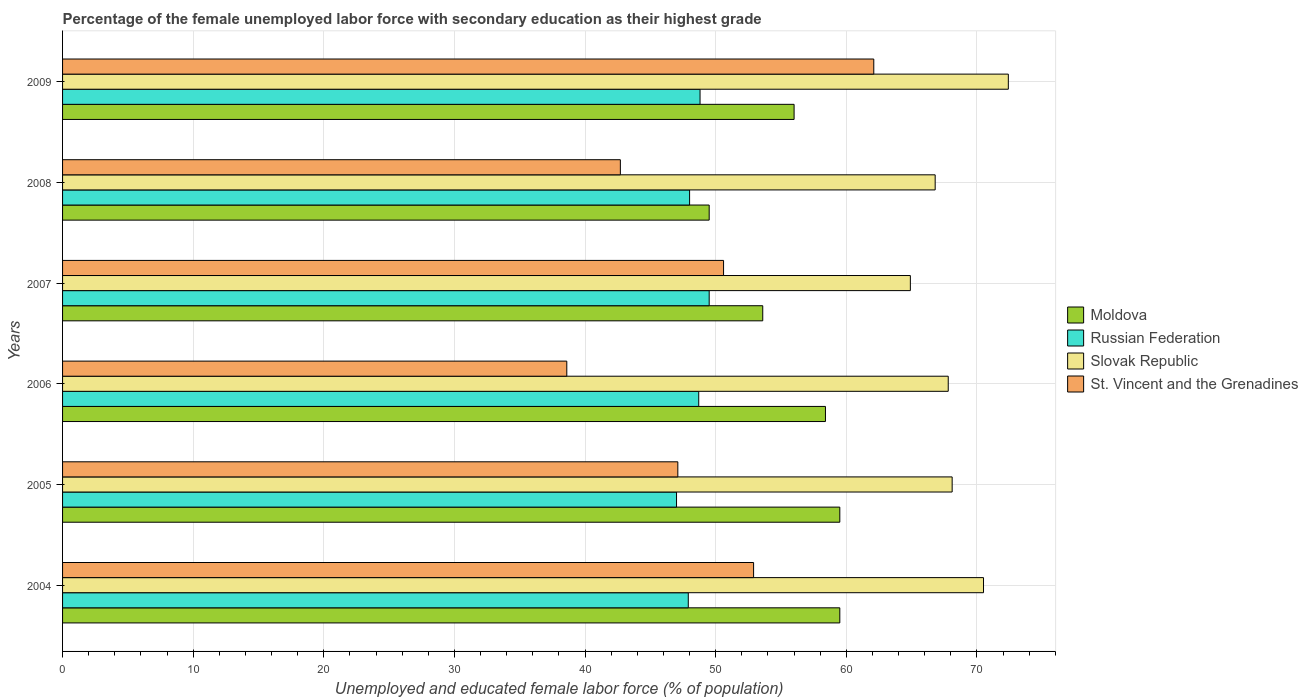How many different coloured bars are there?
Provide a succinct answer. 4. Are the number of bars per tick equal to the number of legend labels?
Your answer should be very brief. Yes. How many bars are there on the 6th tick from the bottom?
Give a very brief answer. 4. In how many cases, is the number of bars for a given year not equal to the number of legend labels?
Provide a succinct answer. 0. What is the percentage of the unemployed female labor force with secondary education in Moldova in 2005?
Ensure brevity in your answer.  59.5. Across all years, what is the maximum percentage of the unemployed female labor force with secondary education in Moldova?
Ensure brevity in your answer.  59.5. In which year was the percentage of the unemployed female labor force with secondary education in Moldova maximum?
Your answer should be compact. 2004. What is the total percentage of the unemployed female labor force with secondary education in St. Vincent and the Grenadines in the graph?
Make the answer very short. 294. What is the difference between the percentage of the unemployed female labor force with secondary education in St. Vincent and the Grenadines in 2006 and that in 2007?
Ensure brevity in your answer.  -12. What is the average percentage of the unemployed female labor force with secondary education in Slovak Republic per year?
Your answer should be very brief. 68.42. In the year 2009, what is the difference between the percentage of the unemployed female labor force with secondary education in Slovak Republic and percentage of the unemployed female labor force with secondary education in St. Vincent and the Grenadines?
Your answer should be compact. 10.3. What is the ratio of the percentage of the unemployed female labor force with secondary education in Russian Federation in 2008 to that in 2009?
Your answer should be compact. 0.98. Is the percentage of the unemployed female labor force with secondary education in Russian Federation in 2004 less than that in 2009?
Provide a succinct answer. Yes. Is the difference between the percentage of the unemployed female labor force with secondary education in Slovak Republic in 2007 and 2009 greater than the difference between the percentage of the unemployed female labor force with secondary education in St. Vincent and the Grenadines in 2007 and 2009?
Provide a short and direct response. Yes. What is the difference between the highest and the second highest percentage of the unemployed female labor force with secondary education in Slovak Republic?
Your answer should be compact. 1.9. What is the difference between the highest and the lowest percentage of the unemployed female labor force with secondary education in Russian Federation?
Keep it short and to the point. 2.5. In how many years, is the percentage of the unemployed female labor force with secondary education in Slovak Republic greater than the average percentage of the unemployed female labor force with secondary education in Slovak Republic taken over all years?
Ensure brevity in your answer.  2. Is the sum of the percentage of the unemployed female labor force with secondary education in Slovak Republic in 2007 and 2008 greater than the maximum percentage of the unemployed female labor force with secondary education in Moldova across all years?
Give a very brief answer. Yes. What does the 4th bar from the top in 2004 represents?
Your response must be concise. Moldova. What does the 2nd bar from the bottom in 2007 represents?
Your answer should be compact. Russian Federation. Is it the case that in every year, the sum of the percentage of the unemployed female labor force with secondary education in St. Vincent and the Grenadines and percentage of the unemployed female labor force with secondary education in Moldova is greater than the percentage of the unemployed female labor force with secondary education in Russian Federation?
Keep it short and to the point. Yes. Are all the bars in the graph horizontal?
Your response must be concise. Yes. What is the difference between two consecutive major ticks on the X-axis?
Ensure brevity in your answer.  10. How many legend labels are there?
Your answer should be very brief. 4. What is the title of the graph?
Offer a very short reply. Percentage of the female unemployed labor force with secondary education as their highest grade. What is the label or title of the X-axis?
Give a very brief answer. Unemployed and educated female labor force (% of population). What is the label or title of the Y-axis?
Offer a terse response. Years. What is the Unemployed and educated female labor force (% of population) of Moldova in 2004?
Keep it short and to the point. 59.5. What is the Unemployed and educated female labor force (% of population) of Russian Federation in 2004?
Provide a short and direct response. 47.9. What is the Unemployed and educated female labor force (% of population) in Slovak Republic in 2004?
Keep it short and to the point. 70.5. What is the Unemployed and educated female labor force (% of population) of St. Vincent and the Grenadines in 2004?
Provide a short and direct response. 52.9. What is the Unemployed and educated female labor force (% of population) in Moldova in 2005?
Your answer should be very brief. 59.5. What is the Unemployed and educated female labor force (% of population) of Slovak Republic in 2005?
Give a very brief answer. 68.1. What is the Unemployed and educated female labor force (% of population) in St. Vincent and the Grenadines in 2005?
Give a very brief answer. 47.1. What is the Unemployed and educated female labor force (% of population) of Moldova in 2006?
Your answer should be very brief. 58.4. What is the Unemployed and educated female labor force (% of population) of Russian Federation in 2006?
Make the answer very short. 48.7. What is the Unemployed and educated female labor force (% of population) of Slovak Republic in 2006?
Offer a terse response. 67.8. What is the Unemployed and educated female labor force (% of population) in St. Vincent and the Grenadines in 2006?
Your response must be concise. 38.6. What is the Unemployed and educated female labor force (% of population) of Moldova in 2007?
Ensure brevity in your answer.  53.6. What is the Unemployed and educated female labor force (% of population) in Russian Federation in 2007?
Make the answer very short. 49.5. What is the Unemployed and educated female labor force (% of population) in Slovak Republic in 2007?
Give a very brief answer. 64.9. What is the Unemployed and educated female labor force (% of population) in St. Vincent and the Grenadines in 2007?
Make the answer very short. 50.6. What is the Unemployed and educated female labor force (% of population) in Moldova in 2008?
Make the answer very short. 49.5. What is the Unemployed and educated female labor force (% of population) in Russian Federation in 2008?
Ensure brevity in your answer.  48. What is the Unemployed and educated female labor force (% of population) in Slovak Republic in 2008?
Your response must be concise. 66.8. What is the Unemployed and educated female labor force (% of population) of St. Vincent and the Grenadines in 2008?
Offer a very short reply. 42.7. What is the Unemployed and educated female labor force (% of population) in Russian Federation in 2009?
Provide a succinct answer. 48.8. What is the Unemployed and educated female labor force (% of population) in Slovak Republic in 2009?
Provide a succinct answer. 72.4. What is the Unemployed and educated female labor force (% of population) of St. Vincent and the Grenadines in 2009?
Make the answer very short. 62.1. Across all years, what is the maximum Unemployed and educated female labor force (% of population) in Moldova?
Offer a very short reply. 59.5. Across all years, what is the maximum Unemployed and educated female labor force (% of population) in Russian Federation?
Ensure brevity in your answer.  49.5. Across all years, what is the maximum Unemployed and educated female labor force (% of population) in Slovak Republic?
Provide a short and direct response. 72.4. Across all years, what is the maximum Unemployed and educated female labor force (% of population) of St. Vincent and the Grenadines?
Your answer should be very brief. 62.1. Across all years, what is the minimum Unemployed and educated female labor force (% of population) in Moldova?
Your response must be concise. 49.5. Across all years, what is the minimum Unemployed and educated female labor force (% of population) in Slovak Republic?
Provide a succinct answer. 64.9. Across all years, what is the minimum Unemployed and educated female labor force (% of population) in St. Vincent and the Grenadines?
Your response must be concise. 38.6. What is the total Unemployed and educated female labor force (% of population) in Moldova in the graph?
Offer a terse response. 336.5. What is the total Unemployed and educated female labor force (% of population) of Russian Federation in the graph?
Provide a succinct answer. 289.9. What is the total Unemployed and educated female labor force (% of population) in Slovak Republic in the graph?
Offer a very short reply. 410.5. What is the total Unemployed and educated female labor force (% of population) of St. Vincent and the Grenadines in the graph?
Keep it short and to the point. 294. What is the difference between the Unemployed and educated female labor force (% of population) in Slovak Republic in 2004 and that in 2005?
Provide a short and direct response. 2.4. What is the difference between the Unemployed and educated female labor force (% of population) in Russian Federation in 2004 and that in 2007?
Offer a very short reply. -1.6. What is the difference between the Unemployed and educated female labor force (% of population) of Slovak Republic in 2004 and that in 2008?
Offer a terse response. 3.7. What is the difference between the Unemployed and educated female labor force (% of population) in Moldova in 2004 and that in 2009?
Ensure brevity in your answer.  3.5. What is the difference between the Unemployed and educated female labor force (% of population) in Russian Federation in 2005 and that in 2006?
Provide a short and direct response. -1.7. What is the difference between the Unemployed and educated female labor force (% of population) in Slovak Republic in 2005 and that in 2006?
Offer a very short reply. 0.3. What is the difference between the Unemployed and educated female labor force (% of population) of St. Vincent and the Grenadines in 2005 and that in 2006?
Your answer should be very brief. 8.5. What is the difference between the Unemployed and educated female labor force (% of population) of Moldova in 2005 and that in 2007?
Give a very brief answer. 5.9. What is the difference between the Unemployed and educated female labor force (% of population) in Russian Federation in 2005 and that in 2007?
Provide a succinct answer. -2.5. What is the difference between the Unemployed and educated female labor force (% of population) of St. Vincent and the Grenadines in 2005 and that in 2007?
Provide a short and direct response. -3.5. What is the difference between the Unemployed and educated female labor force (% of population) of Moldova in 2005 and that in 2009?
Your answer should be very brief. 3.5. What is the difference between the Unemployed and educated female labor force (% of population) in Russian Federation in 2005 and that in 2009?
Ensure brevity in your answer.  -1.8. What is the difference between the Unemployed and educated female labor force (% of population) in Moldova in 2006 and that in 2007?
Your answer should be very brief. 4.8. What is the difference between the Unemployed and educated female labor force (% of population) of Slovak Republic in 2006 and that in 2007?
Offer a very short reply. 2.9. What is the difference between the Unemployed and educated female labor force (% of population) in Slovak Republic in 2006 and that in 2008?
Your answer should be very brief. 1. What is the difference between the Unemployed and educated female labor force (% of population) in St. Vincent and the Grenadines in 2006 and that in 2008?
Provide a succinct answer. -4.1. What is the difference between the Unemployed and educated female labor force (% of population) in St. Vincent and the Grenadines in 2006 and that in 2009?
Ensure brevity in your answer.  -23.5. What is the difference between the Unemployed and educated female labor force (% of population) in Moldova in 2007 and that in 2008?
Provide a short and direct response. 4.1. What is the difference between the Unemployed and educated female labor force (% of population) in St. Vincent and the Grenadines in 2007 and that in 2008?
Keep it short and to the point. 7.9. What is the difference between the Unemployed and educated female labor force (% of population) of Moldova in 2007 and that in 2009?
Provide a short and direct response. -2.4. What is the difference between the Unemployed and educated female labor force (% of population) in Russian Federation in 2008 and that in 2009?
Ensure brevity in your answer.  -0.8. What is the difference between the Unemployed and educated female labor force (% of population) in Slovak Republic in 2008 and that in 2009?
Provide a short and direct response. -5.6. What is the difference between the Unemployed and educated female labor force (% of population) of St. Vincent and the Grenadines in 2008 and that in 2009?
Your answer should be compact. -19.4. What is the difference between the Unemployed and educated female labor force (% of population) in Moldova in 2004 and the Unemployed and educated female labor force (% of population) in Slovak Republic in 2005?
Your response must be concise. -8.6. What is the difference between the Unemployed and educated female labor force (% of population) of Russian Federation in 2004 and the Unemployed and educated female labor force (% of population) of Slovak Republic in 2005?
Provide a short and direct response. -20.2. What is the difference between the Unemployed and educated female labor force (% of population) of Russian Federation in 2004 and the Unemployed and educated female labor force (% of population) of St. Vincent and the Grenadines in 2005?
Provide a short and direct response. 0.8. What is the difference between the Unemployed and educated female labor force (% of population) of Slovak Republic in 2004 and the Unemployed and educated female labor force (% of population) of St. Vincent and the Grenadines in 2005?
Keep it short and to the point. 23.4. What is the difference between the Unemployed and educated female labor force (% of population) in Moldova in 2004 and the Unemployed and educated female labor force (% of population) in Russian Federation in 2006?
Offer a very short reply. 10.8. What is the difference between the Unemployed and educated female labor force (% of population) of Moldova in 2004 and the Unemployed and educated female labor force (% of population) of Slovak Republic in 2006?
Provide a succinct answer. -8.3. What is the difference between the Unemployed and educated female labor force (% of population) in Moldova in 2004 and the Unemployed and educated female labor force (% of population) in St. Vincent and the Grenadines in 2006?
Offer a very short reply. 20.9. What is the difference between the Unemployed and educated female labor force (% of population) in Russian Federation in 2004 and the Unemployed and educated female labor force (% of population) in Slovak Republic in 2006?
Provide a short and direct response. -19.9. What is the difference between the Unemployed and educated female labor force (% of population) in Slovak Republic in 2004 and the Unemployed and educated female labor force (% of population) in St. Vincent and the Grenadines in 2006?
Give a very brief answer. 31.9. What is the difference between the Unemployed and educated female labor force (% of population) in Moldova in 2004 and the Unemployed and educated female labor force (% of population) in Russian Federation in 2007?
Keep it short and to the point. 10. What is the difference between the Unemployed and educated female labor force (% of population) of Moldova in 2004 and the Unemployed and educated female labor force (% of population) of Slovak Republic in 2007?
Make the answer very short. -5.4. What is the difference between the Unemployed and educated female labor force (% of population) of Moldova in 2004 and the Unemployed and educated female labor force (% of population) of St. Vincent and the Grenadines in 2007?
Provide a succinct answer. 8.9. What is the difference between the Unemployed and educated female labor force (% of population) in Russian Federation in 2004 and the Unemployed and educated female labor force (% of population) in Slovak Republic in 2007?
Ensure brevity in your answer.  -17. What is the difference between the Unemployed and educated female labor force (% of population) in Russian Federation in 2004 and the Unemployed and educated female labor force (% of population) in St. Vincent and the Grenadines in 2007?
Provide a short and direct response. -2.7. What is the difference between the Unemployed and educated female labor force (% of population) in Slovak Republic in 2004 and the Unemployed and educated female labor force (% of population) in St. Vincent and the Grenadines in 2007?
Make the answer very short. 19.9. What is the difference between the Unemployed and educated female labor force (% of population) in Moldova in 2004 and the Unemployed and educated female labor force (% of population) in St. Vincent and the Grenadines in 2008?
Offer a very short reply. 16.8. What is the difference between the Unemployed and educated female labor force (% of population) in Russian Federation in 2004 and the Unemployed and educated female labor force (% of population) in Slovak Republic in 2008?
Keep it short and to the point. -18.9. What is the difference between the Unemployed and educated female labor force (% of population) in Slovak Republic in 2004 and the Unemployed and educated female labor force (% of population) in St. Vincent and the Grenadines in 2008?
Your response must be concise. 27.8. What is the difference between the Unemployed and educated female labor force (% of population) of Moldova in 2004 and the Unemployed and educated female labor force (% of population) of Russian Federation in 2009?
Provide a succinct answer. 10.7. What is the difference between the Unemployed and educated female labor force (% of population) of Russian Federation in 2004 and the Unemployed and educated female labor force (% of population) of Slovak Republic in 2009?
Make the answer very short. -24.5. What is the difference between the Unemployed and educated female labor force (% of population) in Moldova in 2005 and the Unemployed and educated female labor force (% of population) in St. Vincent and the Grenadines in 2006?
Ensure brevity in your answer.  20.9. What is the difference between the Unemployed and educated female labor force (% of population) of Russian Federation in 2005 and the Unemployed and educated female labor force (% of population) of Slovak Republic in 2006?
Offer a very short reply. -20.8. What is the difference between the Unemployed and educated female labor force (% of population) of Russian Federation in 2005 and the Unemployed and educated female labor force (% of population) of St. Vincent and the Grenadines in 2006?
Your answer should be very brief. 8.4. What is the difference between the Unemployed and educated female labor force (% of population) in Slovak Republic in 2005 and the Unemployed and educated female labor force (% of population) in St. Vincent and the Grenadines in 2006?
Keep it short and to the point. 29.5. What is the difference between the Unemployed and educated female labor force (% of population) in Moldova in 2005 and the Unemployed and educated female labor force (% of population) in St. Vincent and the Grenadines in 2007?
Your response must be concise. 8.9. What is the difference between the Unemployed and educated female labor force (% of population) of Russian Federation in 2005 and the Unemployed and educated female labor force (% of population) of Slovak Republic in 2007?
Provide a succinct answer. -17.9. What is the difference between the Unemployed and educated female labor force (% of population) of Slovak Republic in 2005 and the Unemployed and educated female labor force (% of population) of St. Vincent and the Grenadines in 2007?
Your answer should be very brief. 17.5. What is the difference between the Unemployed and educated female labor force (% of population) of Russian Federation in 2005 and the Unemployed and educated female labor force (% of population) of Slovak Republic in 2008?
Your response must be concise. -19.8. What is the difference between the Unemployed and educated female labor force (% of population) of Slovak Republic in 2005 and the Unemployed and educated female labor force (% of population) of St. Vincent and the Grenadines in 2008?
Your response must be concise. 25.4. What is the difference between the Unemployed and educated female labor force (% of population) of Russian Federation in 2005 and the Unemployed and educated female labor force (% of population) of Slovak Republic in 2009?
Offer a terse response. -25.4. What is the difference between the Unemployed and educated female labor force (% of population) in Russian Federation in 2005 and the Unemployed and educated female labor force (% of population) in St. Vincent and the Grenadines in 2009?
Your answer should be very brief. -15.1. What is the difference between the Unemployed and educated female labor force (% of population) of Slovak Republic in 2005 and the Unemployed and educated female labor force (% of population) of St. Vincent and the Grenadines in 2009?
Ensure brevity in your answer.  6. What is the difference between the Unemployed and educated female labor force (% of population) of Moldova in 2006 and the Unemployed and educated female labor force (% of population) of Russian Federation in 2007?
Keep it short and to the point. 8.9. What is the difference between the Unemployed and educated female labor force (% of population) in Russian Federation in 2006 and the Unemployed and educated female labor force (% of population) in Slovak Republic in 2007?
Give a very brief answer. -16.2. What is the difference between the Unemployed and educated female labor force (% of population) in Slovak Republic in 2006 and the Unemployed and educated female labor force (% of population) in St. Vincent and the Grenadines in 2007?
Your response must be concise. 17.2. What is the difference between the Unemployed and educated female labor force (% of population) in Moldova in 2006 and the Unemployed and educated female labor force (% of population) in Russian Federation in 2008?
Ensure brevity in your answer.  10.4. What is the difference between the Unemployed and educated female labor force (% of population) in Moldova in 2006 and the Unemployed and educated female labor force (% of population) in Slovak Republic in 2008?
Provide a short and direct response. -8.4. What is the difference between the Unemployed and educated female labor force (% of population) in Moldova in 2006 and the Unemployed and educated female labor force (% of population) in St. Vincent and the Grenadines in 2008?
Your answer should be very brief. 15.7. What is the difference between the Unemployed and educated female labor force (% of population) of Russian Federation in 2006 and the Unemployed and educated female labor force (% of population) of Slovak Republic in 2008?
Ensure brevity in your answer.  -18.1. What is the difference between the Unemployed and educated female labor force (% of population) in Russian Federation in 2006 and the Unemployed and educated female labor force (% of population) in St. Vincent and the Grenadines in 2008?
Make the answer very short. 6. What is the difference between the Unemployed and educated female labor force (% of population) of Slovak Republic in 2006 and the Unemployed and educated female labor force (% of population) of St. Vincent and the Grenadines in 2008?
Keep it short and to the point. 25.1. What is the difference between the Unemployed and educated female labor force (% of population) in Moldova in 2006 and the Unemployed and educated female labor force (% of population) in Slovak Republic in 2009?
Your response must be concise. -14. What is the difference between the Unemployed and educated female labor force (% of population) in Moldova in 2006 and the Unemployed and educated female labor force (% of population) in St. Vincent and the Grenadines in 2009?
Give a very brief answer. -3.7. What is the difference between the Unemployed and educated female labor force (% of population) of Russian Federation in 2006 and the Unemployed and educated female labor force (% of population) of Slovak Republic in 2009?
Your answer should be very brief. -23.7. What is the difference between the Unemployed and educated female labor force (% of population) in Moldova in 2007 and the Unemployed and educated female labor force (% of population) in Russian Federation in 2008?
Your answer should be compact. 5.6. What is the difference between the Unemployed and educated female labor force (% of population) of Moldova in 2007 and the Unemployed and educated female labor force (% of population) of Slovak Republic in 2008?
Keep it short and to the point. -13.2. What is the difference between the Unemployed and educated female labor force (% of population) of Russian Federation in 2007 and the Unemployed and educated female labor force (% of population) of Slovak Republic in 2008?
Make the answer very short. -17.3. What is the difference between the Unemployed and educated female labor force (% of population) of Russian Federation in 2007 and the Unemployed and educated female labor force (% of population) of St. Vincent and the Grenadines in 2008?
Keep it short and to the point. 6.8. What is the difference between the Unemployed and educated female labor force (% of population) of Slovak Republic in 2007 and the Unemployed and educated female labor force (% of population) of St. Vincent and the Grenadines in 2008?
Make the answer very short. 22.2. What is the difference between the Unemployed and educated female labor force (% of population) in Moldova in 2007 and the Unemployed and educated female labor force (% of population) in Slovak Republic in 2009?
Your answer should be compact. -18.8. What is the difference between the Unemployed and educated female labor force (% of population) of Russian Federation in 2007 and the Unemployed and educated female labor force (% of population) of Slovak Republic in 2009?
Give a very brief answer. -22.9. What is the difference between the Unemployed and educated female labor force (% of population) in Russian Federation in 2007 and the Unemployed and educated female labor force (% of population) in St. Vincent and the Grenadines in 2009?
Give a very brief answer. -12.6. What is the difference between the Unemployed and educated female labor force (% of population) of Slovak Republic in 2007 and the Unemployed and educated female labor force (% of population) of St. Vincent and the Grenadines in 2009?
Make the answer very short. 2.8. What is the difference between the Unemployed and educated female labor force (% of population) in Moldova in 2008 and the Unemployed and educated female labor force (% of population) in Slovak Republic in 2009?
Your answer should be compact. -22.9. What is the difference between the Unemployed and educated female labor force (% of population) in Moldova in 2008 and the Unemployed and educated female labor force (% of population) in St. Vincent and the Grenadines in 2009?
Provide a succinct answer. -12.6. What is the difference between the Unemployed and educated female labor force (% of population) in Russian Federation in 2008 and the Unemployed and educated female labor force (% of population) in Slovak Republic in 2009?
Make the answer very short. -24.4. What is the difference between the Unemployed and educated female labor force (% of population) in Russian Federation in 2008 and the Unemployed and educated female labor force (% of population) in St. Vincent and the Grenadines in 2009?
Your answer should be compact. -14.1. What is the difference between the Unemployed and educated female labor force (% of population) in Slovak Republic in 2008 and the Unemployed and educated female labor force (% of population) in St. Vincent and the Grenadines in 2009?
Offer a very short reply. 4.7. What is the average Unemployed and educated female labor force (% of population) of Moldova per year?
Make the answer very short. 56.08. What is the average Unemployed and educated female labor force (% of population) of Russian Federation per year?
Offer a terse response. 48.32. What is the average Unemployed and educated female labor force (% of population) in Slovak Republic per year?
Provide a short and direct response. 68.42. In the year 2004, what is the difference between the Unemployed and educated female labor force (% of population) in Moldova and Unemployed and educated female labor force (% of population) in Russian Federation?
Your answer should be compact. 11.6. In the year 2004, what is the difference between the Unemployed and educated female labor force (% of population) of Moldova and Unemployed and educated female labor force (% of population) of Slovak Republic?
Give a very brief answer. -11. In the year 2004, what is the difference between the Unemployed and educated female labor force (% of population) in Russian Federation and Unemployed and educated female labor force (% of population) in Slovak Republic?
Keep it short and to the point. -22.6. In the year 2004, what is the difference between the Unemployed and educated female labor force (% of population) in Slovak Republic and Unemployed and educated female labor force (% of population) in St. Vincent and the Grenadines?
Your response must be concise. 17.6. In the year 2005, what is the difference between the Unemployed and educated female labor force (% of population) in Moldova and Unemployed and educated female labor force (% of population) in Russian Federation?
Offer a terse response. 12.5. In the year 2005, what is the difference between the Unemployed and educated female labor force (% of population) in Moldova and Unemployed and educated female labor force (% of population) in St. Vincent and the Grenadines?
Keep it short and to the point. 12.4. In the year 2005, what is the difference between the Unemployed and educated female labor force (% of population) of Russian Federation and Unemployed and educated female labor force (% of population) of Slovak Republic?
Keep it short and to the point. -21.1. In the year 2006, what is the difference between the Unemployed and educated female labor force (% of population) of Moldova and Unemployed and educated female labor force (% of population) of Russian Federation?
Make the answer very short. 9.7. In the year 2006, what is the difference between the Unemployed and educated female labor force (% of population) of Moldova and Unemployed and educated female labor force (% of population) of Slovak Republic?
Your answer should be compact. -9.4. In the year 2006, what is the difference between the Unemployed and educated female labor force (% of population) of Moldova and Unemployed and educated female labor force (% of population) of St. Vincent and the Grenadines?
Ensure brevity in your answer.  19.8. In the year 2006, what is the difference between the Unemployed and educated female labor force (% of population) in Russian Federation and Unemployed and educated female labor force (% of population) in Slovak Republic?
Offer a terse response. -19.1. In the year 2006, what is the difference between the Unemployed and educated female labor force (% of population) of Russian Federation and Unemployed and educated female labor force (% of population) of St. Vincent and the Grenadines?
Provide a short and direct response. 10.1. In the year 2006, what is the difference between the Unemployed and educated female labor force (% of population) of Slovak Republic and Unemployed and educated female labor force (% of population) of St. Vincent and the Grenadines?
Make the answer very short. 29.2. In the year 2007, what is the difference between the Unemployed and educated female labor force (% of population) of Russian Federation and Unemployed and educated female labor force (% of population) of Slovak Republic?
Ensure brevity in your answer.  -15.4. In the year 2007, what is the difference between the Unemployed and educated female labor force (% of population) of Russian Federation and Unemployed and educated female labor force (% of population) of St. Vincent and the Grenadines?
Provide a succinct answer. -1.1. In the year 2008, what is the difference between the Unemployed and educated female labor force (% of population) of Moldova and Unemployed and educated female labor force (% of population) of Slovak Republic?
Your answer should be compact. -17.3. In the year 2008, what is the difference between the Unemployed and educated female labor force (% of population) in Moldova and Unemployed and educated female labor force (% of population) in St. Vincent and the Grenadines?
Keep it short and to the point. 6.8. In the year 2008, what is the difference between the Unemployed and educated female labor force (% of population) in Russian Federation and Unemployed and educated female labor force (% of population) in Slovak Republic?
Your response must be concise. -18.8. In the year 2008, what is the difference between the Unemployed and educated female labor force (% of population) in Russian Federation and Unemployed and educated female labor force (% of population) in St. Vincent and the Grenadines?
Offer a very short reply. 5.3. In the year 2008, what is the difference between the Unemployed and educated female labor force (% of population) in Slovak Republic and Unemployed and educated female labor force (% of population) in St. Vincent and the Grenadines?
Make the answer very short. 24.1. In the year 2009, what is the difference between the Unemployed and educated female labor force (% of population) in Moldova and Unemployed and educated female labor force (% of population) in Russian Federation?
Provide a succinct answer. 7.2. In the year 2009, what is the difference between the Unemployed and educated female labor force (% of population) in Moldova and Unemployed and educated female labor force (% of population) in Slovak Republic?
Provide a short and direct response. -16.4. In the year 2009, what is the difference between the Unemployed and educated female labor force (% of population) in Moldova and Unemployed and educated female labor force (% of population) in St. Vincent and the Grenadines?
Your answer should be compact. -6.1. In the year 2009, what is the difference between the Unemployed and educated female labor force (% of population) in Russian Federation and Unemployed and educated female labor force (% of population) in Slovak Republic?
Your answer should be very brief. -23.6. In the year 2009, what is the difference between the Unemployed and educated female labor force (% of population) in Russian Federation and Unemployed and educated female labor force (% of population) in St. Vincent and the Grenadines?
Provide a short and direct response. -13.3. What is the ratio of the Unemployed and educated female labor force (% of population) in Moldova in 2004 to that in 2005?
Give a very brief answer. 1. What is the ratio of the Unemployed and educated female labor force (% of population) in Russian Federation in 2004 to that in 2005?
Keep it short and to the point. 1.02. What is the ratio of the Unemployed and educated female labor force (% of population) in Slovak Republic in 2004 to that in 2005?
Offer a terse response. 1.04. What is the ratio of the Unemployed and educated female labor force (% of population) in St. Vincent and the Grenadines in 2004 to that in 2005?
Provide a short and direct response. 1.12. What is the ratio of the Unemployed and educated female labor force (% of population) in Moldova in 2004 to that in 2006?
Your response must be concise. 1.02. What is the ratio of the Unemployed and educated female labor force (% of population) in Russian Federation in 2004 to that in 2006?
Give a very brief answer. 0.98. What is the ratio of the Unemployed and educated female labor force (% of population) of Slovak Republic in 2004 to that in 2006?
Provide a short and direct response. 1.04. What is the ratio of the Unemployed and educated female labor force (% of population) of St. Vincent and the Grenadines in 2004 to that in 2006?
Your response must be concise. 1.37. What is the ratio of the Unemployed and educated female labor force (% of population) of Moldova in 2004 to that in 2007?
Your response must be concise. 1.11. What is the ratio of the Unemployed and educated female labor force (% of population) of Slovak Republic in 2004 to that in 2007?
Offer a terse response. 1.09. What is the ratio of the Unemployed and educated female labor force (% of population) of St. Vincent and the Grenadines in 2004 to that in 2007?
Provide a short and direct response. 1.05. What is the ratio of the Unemployed and educated female labor force (% of population) in Moldova in 2004 to that in 2008?
Offer a very short reply. 1.2. What is the ratio of the Unemployed and educated female labor force (% of population) of Russian Federation in 2004 to that in 2008?
Make the answer very short. 1. What is the ratio of the Unemployed and educated female labor force (% of population) in Slovak Republic in 2004 to that in 2008?
Your answer should be compact. 1.06. What is the ratio of the Unemployed and educated female labor force (% of population) of St. Vincent and the Grenadines in 2004 to that in 2008?
Offer a terse response. 1.24. What is the ratio of the Unemployed and educated female labor force (% of population) of Moldova in 2004 to that in 2009?
Ensure brevity in your answer.  1.06. What is the ratio of the Unemployed and educated female labor force (% of population) in Russian Federation in 2004 to that in 2009?
Provide a short and direct response. 0.98. What is the ratio of the Unemployed and educated female labor force (% of population) of Slovak Republic in 2004 to that in 2009?
Keep it short and to the point. 0.97. What is the ratio of the Unemployed and educated female labor force (% of population) of St. Vincent and the Grenadines in 2004 to that in 2009?
Provide a succinct answer. 0.85. What is the ratio of the Unemployed and educated female labor force (% of population) of Moldova in 2005 to that in 2006?
Provide a short and direct response. 1.02. What is the ratio of the Unemployed and educated female labor force (% of population) of Russian Federation in 2005 to that in 2006?
Offer a terse response. 0.97. What is the ratio of the Unemployed and educated female labor force (% of population) in Slovak Republic in 2005 to that in 2006?
Offer a very short reply. 1. What is the ratio of the Unemployed and educated female labor force (% of population) in St. Vincent and the Grenadines in 2005 to that in 2006?
Keep it short and to the point. 1.22. What is the ratio of the Unemployed and educated female labor force (% of population) of Moldova in 2005 to that in 2007?
Keep it short and to the point. 1.11. What is the ratio of the Unemployed and educated female labor force (% of population) in Russian Federation in 2005 to that in 2007?
Provide a succinct answer. 0.95. What is the ratio of the Unemployed and educated female labor force (% of population) of Slovak Republic in 2005 to that in 2007?
Your response must be concise. 1.05. What is the ratio of the Unemployed and educated female labor force (% of population) in St. Vincent and the Grenadines in 2005 to that in 2007?
Provide a short and direct response. 0.93. What is the ratio of the Unemployed and educated female labor force (% of population) in Moldova in 2005 to that in 2008?
Offer a terse response. 1.2. What is the ratio of the Unemployed and educated female labor force (% of population) of Russian Federation in 2005 to that in 2008?
Your response must be concise. 0.98. What is the ratio of the Unemployed and educated female labor force (% of population) of Slovak Republic in 2005 to that in 2008?
Your answer should be very brief. 1.02. What is the ratio of the Unemployed and educated female labor force (% of population) in St. Vincent and the Grenadines in 2005 to that in 2008?
Make the answer very short. 1.1. What is the ratio of the Unemployed and educated female labor force (% of population) of Russian Federation in 2005 to that in 2009?
Keep it short and to the point. 0.96. What is the ratio of the Unemployed and educated female labor force (% of population) of Slovak Republic in 2005 to that in 2009?
Give a very brief answer. 0.94. What is the ratio of the Unemployed and educated female labor force (% of population) of St. Vincent and the Grenadines in 2005 to that in 2009?
Make the answer very short. 0.76. What is the ratio of the Unemployed and educated female labor force (% of population) of Moldova in 2006 to that in 2007?
Make the answer very short. 1.09. What is the ratio of the Unemployed and educated female labor force (% of population) in Russian Federation in 2006 to that in 2007?
Your answer should be compact. 0.98. What is the ratio of the Unemployed and educated female labor force (% of population) of Slovak Republic in 2006 to that in 2007?
Your answer should be very brief. 1.04. What is the ratio of the Unemployed and educated female labor force (% of population) in St. Vincent and the Grenadines in 2006 to that in 2007?
Your answer should be compact. 0.76. What is the ratio of the Unemployed and educated female labor force (% of population) of Moldova in 2006 to that in 2008?
Provide a short and direct response. 1.18. What is the ratio of the Unemployed and educated female labor force (% of population) of Russian Federation in 2006 to that in 2008?
Provide a succinct answer. 1.01. What is the ratio of the Unemployed and educated female labor force (% of population) of St. Vincent and the Grenadines in 2006 to that in 2008?
Ensure brevity in your answer.  0.9. What is the ratio of the Unemployed and educated female labor force (% of population) of Moldova in 2006 to that in 2009?
Keep it short and to the point. 1.04. What is the ratio of the Unemployed and educated female labor force (% of population) of Slovak Republic in 2006 to that in 2009?
Your answer should be compact. 0.94. What is the ratio of the Unemployed and educated female labor force (% of population) in St. Vincent and the Grenadines in 2006 to that in 2009?
Provide a succinct answer. 0.62. What is the ratio of the Unemployed and educated female labor force (% of population) in Moldova in 2007 to that in 2008?
Offer a very short reply. 1.08. What is the ratio of the Unemployed and educated female labor force (% of population) of Russian Federation in 2007 to that in 2008?
Your response must be concise. 1.03. What is the ratio of the Unemployed and educated female labor force (% of population) of Slovak Republic in 2007 to that in 2008?
Make the answer very short. 0.97. What is the ratio of the Unemployed and educated female labor force (% of population) in St. Vincent and the Grenadines in 2007 to that in 2008?
Give a very brief answer. 1.19. What is the ratio of the Unemployed and educated female labor force (% of population) of Moldova in 2007 to that in 2009?
Offer a very short reply. 0.96. What is the ratio of the Unemployed and educated female labor force (% of population) in Russian Federation in 2007 to that in 2009?
Give a very brief answer. 1.01. What is the ratio of the Unemployed and educated female labor force (% of population) in Slovak Republic in 2007 to that in 2009?
Your answer should be very brief. 0.9. What is the ratio of the Unemployed and educated female labor force (% of population) in St. Vincent and the Grenadines in 2007 to that in 2009?
Offer a terse response. 0.81. What is the ratio of the Unemployed and educated female labor force (% of population) in Moldova in 2008 to that in 2009?
Offer a terse response. 0.88. What is the ratio of the Unemployed and educated female labor force (% of population) in Russian Federation in 2008 to that in 2009?
Give a very brief answer. 0.98. What is the ratio of the Unemployed and educated female labor force (% of population) in Slovak Republic in 2008 to that in 2009?
Provide a short and direct response. 0.92. What is the ratio of the Unemployed and educated female labor force (% of population) of St. Vincent and the Grenadines in 2008 to that in 2009?
Your answer should be very brief. 0.69. What is the difference between the highest and the second highest Unemployed and educated female labor force (% of population) in Russian Federation?
Offer a terse response. 0.7. What is the difference between the highest and the second highest Unemployed and educated female labor force (% of population) of Slovak Republic?
Make the answer very short. 1.9. What is the difference between the highest and the lowest Unemployed and educated female labor force (% of population) in Slovak Republic?
Ensure brevity in your answer.  7.5. What is the difference between the highest and the lowest Unemployed and educated female labor force (% of population) of St. Vincent and the Grenadines?
Offer a very short reply. 23.5. 